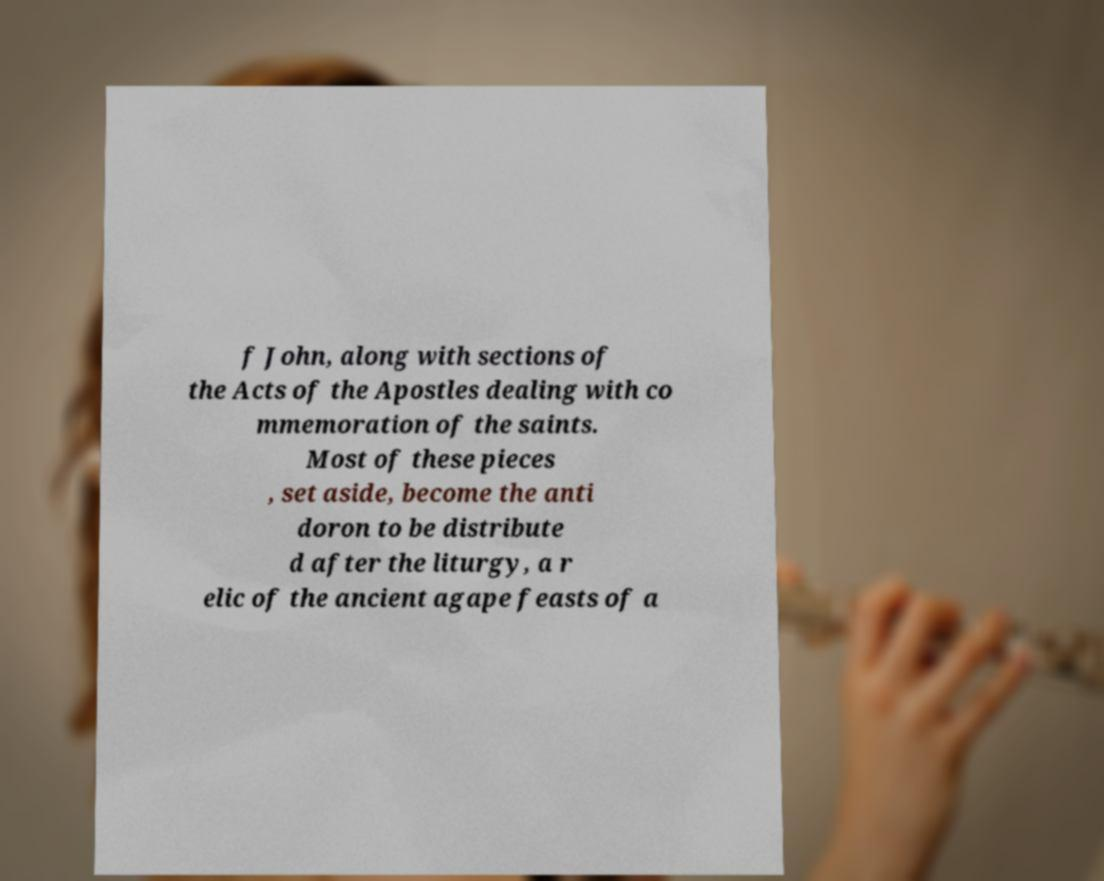Please read and relay the text visible in this image. What does it say? f John, along with sections of the Acts of the Apostles dealing with co mmemoration of the saints. Most of these pieces , set aside, become the anti doron to be distribute d after the liturgy, a r elic of the ancient agape feasts of a 